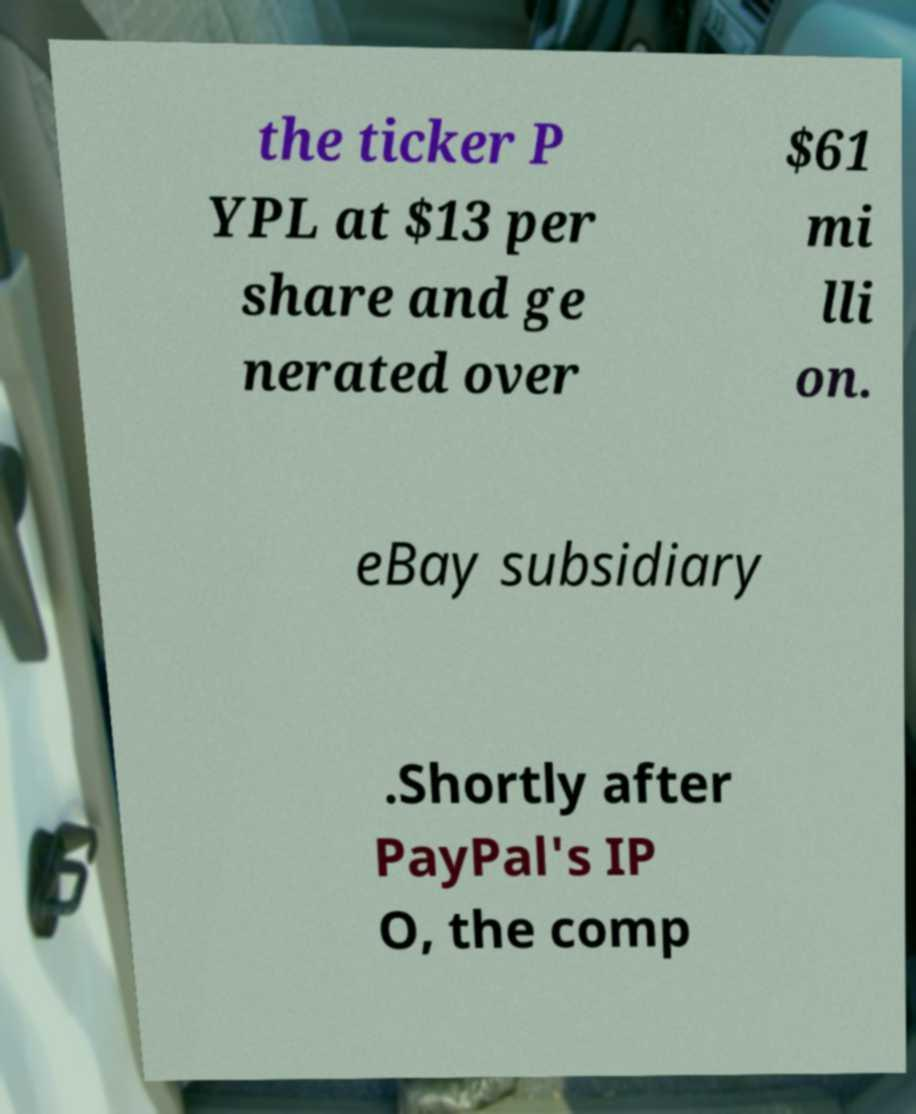For documentation purposes, I need the text within this image transcribed. Could you provide that? the ticker P YPL at $13 per share and ge nerated over $61 mi lli on. eBay subsidiary .Shortly after PayPal's IP O, the comp 